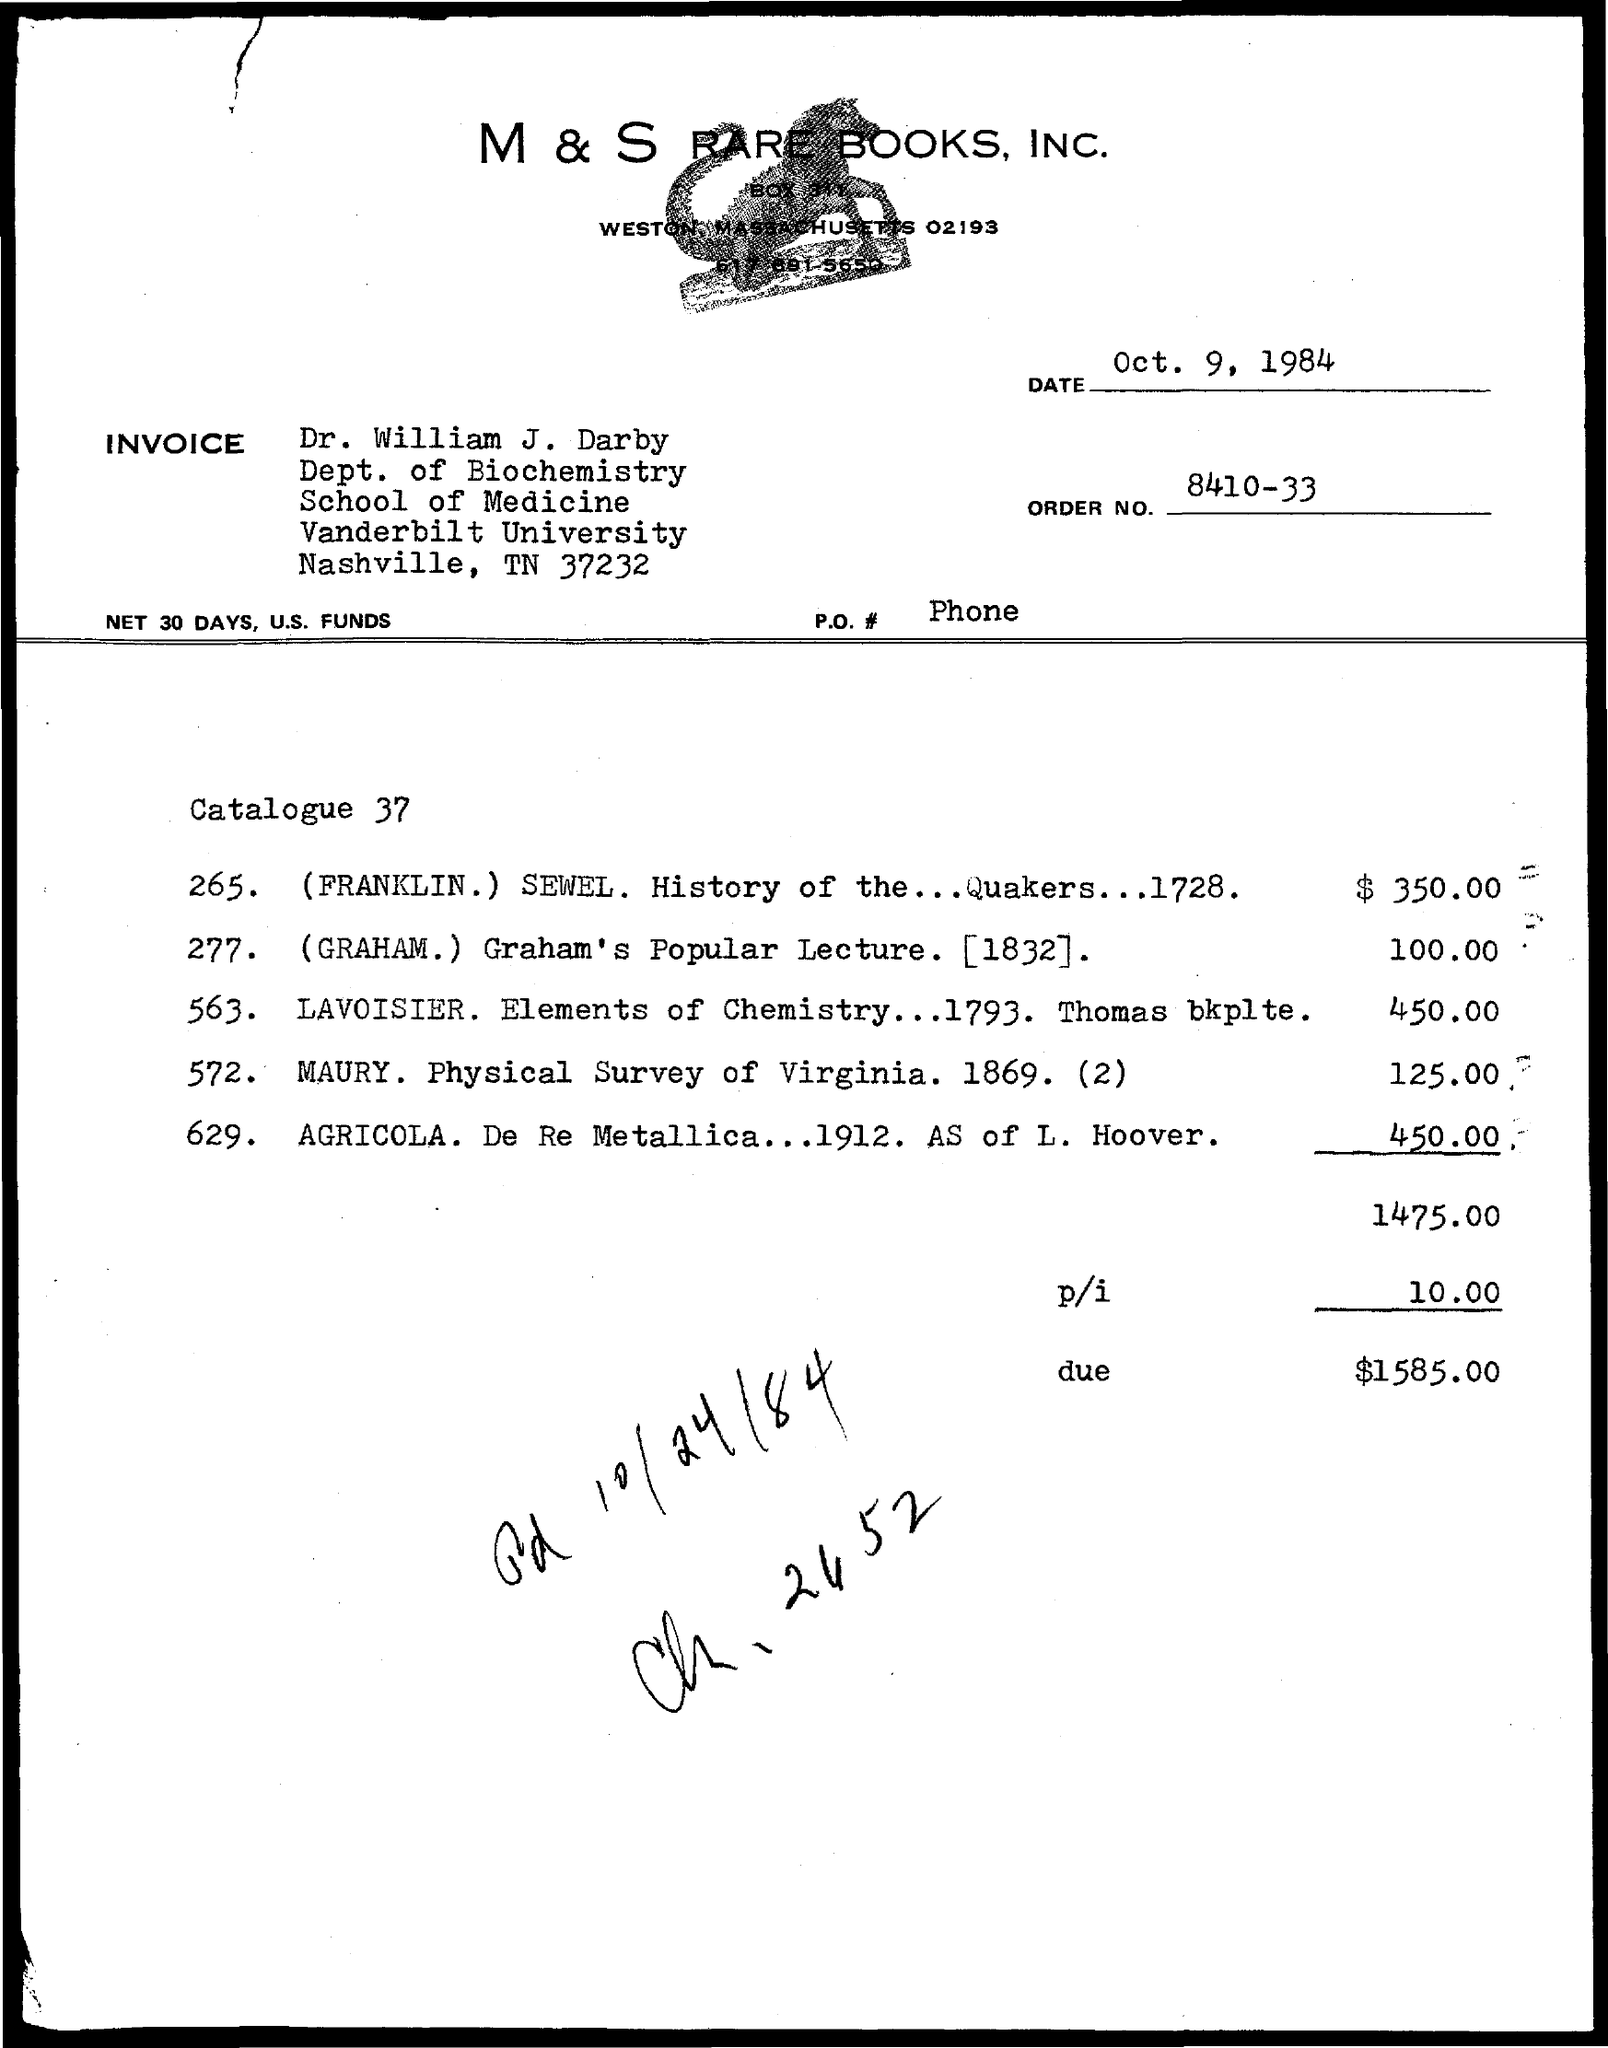What is the order no mentioned in the given page ?
Offer a terse response. 8410-33. What is the date mentioned in the given page ?
Your answer should be very brief. Oct. 9, 1984. To which department dr. william j. darby belongs to ?
Make the answer very short. Dept. of biochemistry. What is the name of the university mentioned in the given page ?
Give a very brief answer. Vanderbilt university. What is the due amount mentioned in the given page ?
Your answer should be very brief. $ 1585.00. 